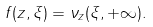Convert formula to latex. <formula><loc_0><loc_0><loc_500><loc_500>f ( z , \xi ) = \nu _ { z } ( \xi , + \infty ) .</formula> 